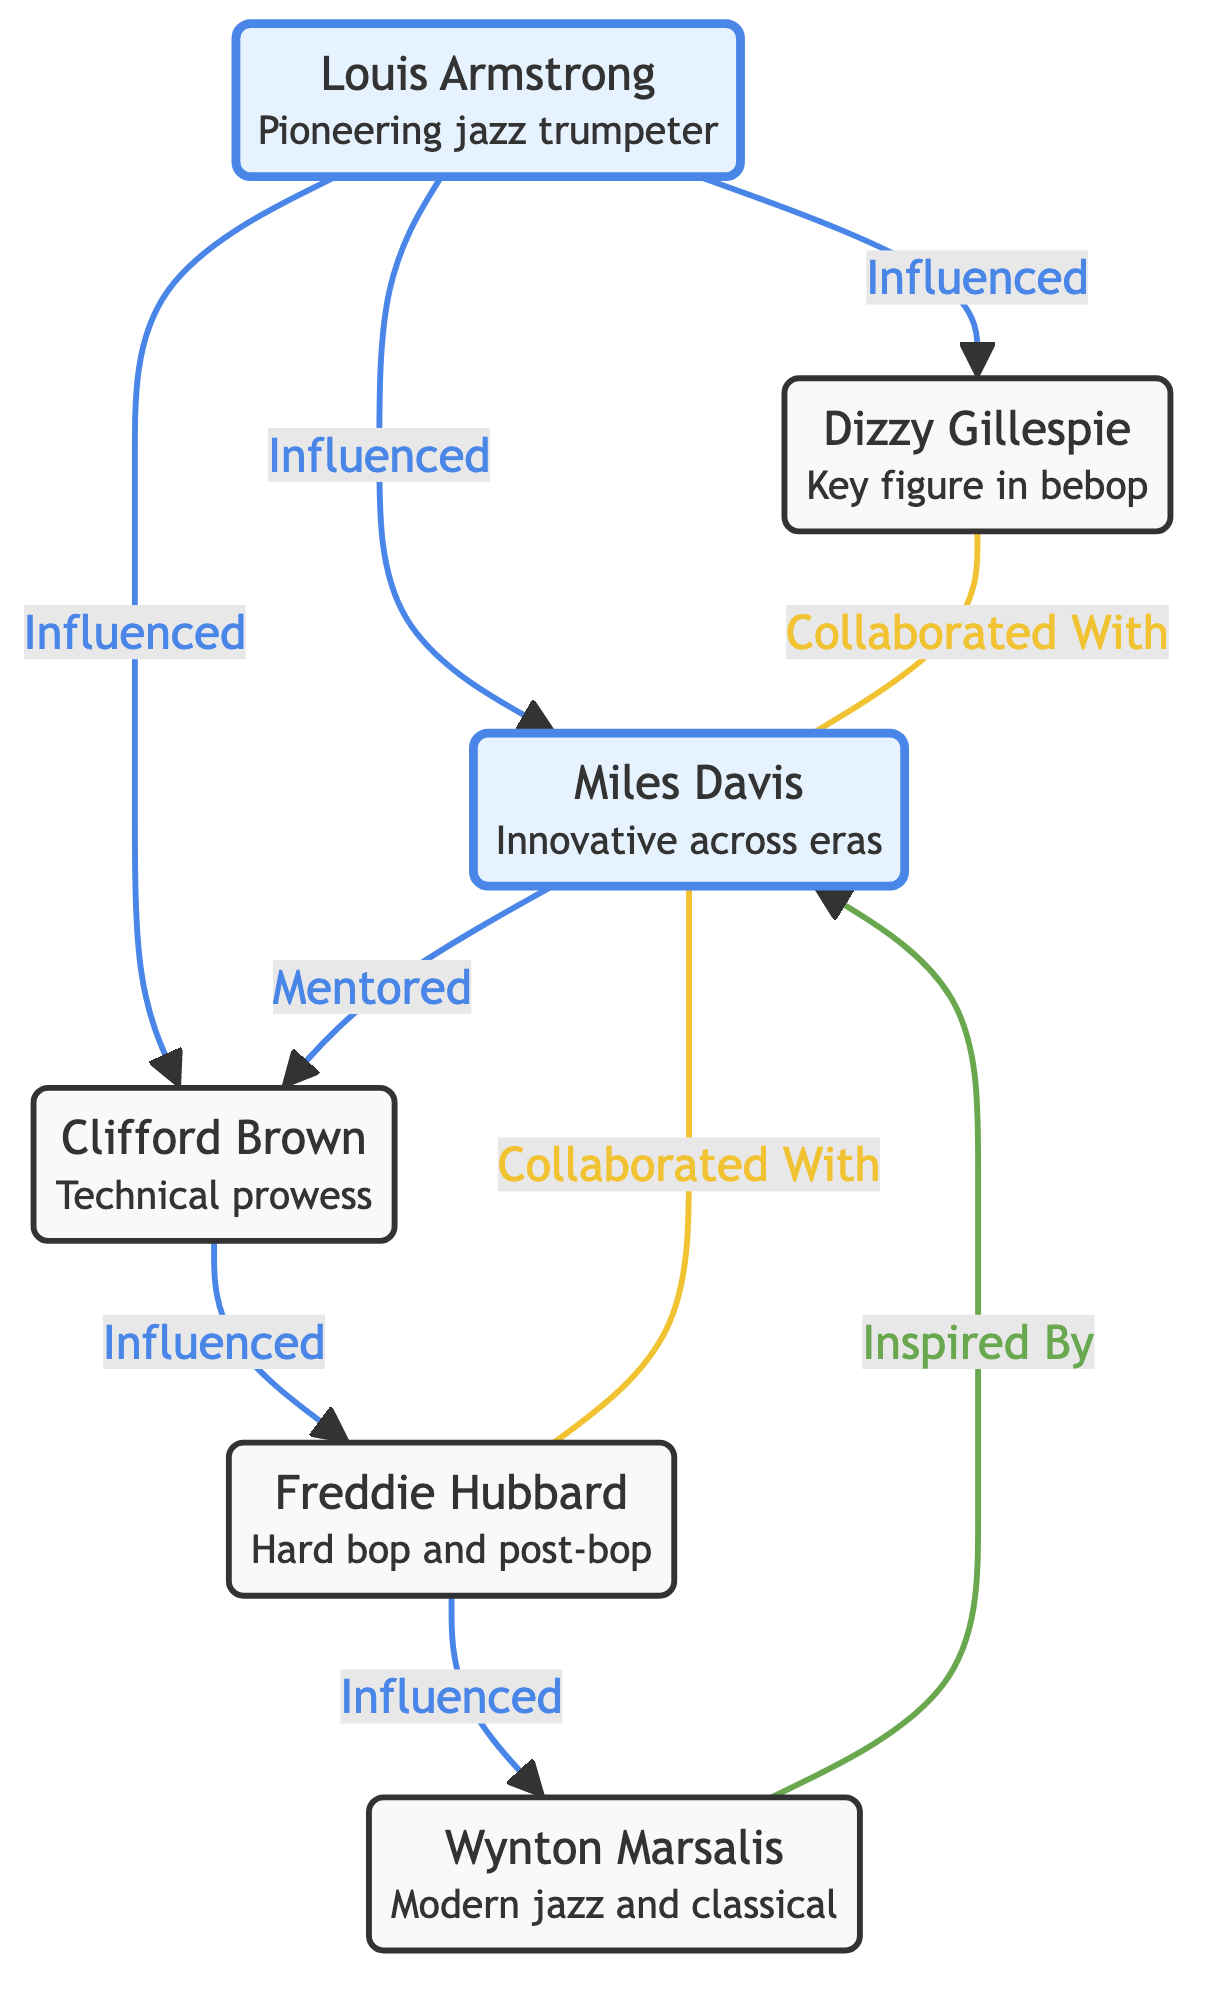What is the total number of trumpet players in the diagram? The diagram features a list of nodes that represent individual trumpet players. By counting each unique player node, we find there are six players represented.
Answer: 6 Who influenced Dizzy Gillespie? The arrow originating from Louis Armstrong pointing to Dizzy Gillespie indicates that he influenced Gillespie. Thus, Louis Armstrong is the correct answer based on the relationship shown in the diagram.
Answer: Louis Armstrong Which musician did Miles Davis mentor? The arrow leading from Miles Davis to Clifford Brown shows that Davis mentored Brown. This relationship is clearly indicated in the network, making the answer easy to identify.
Answer: Clifford Brown How many collaborations are depicted in the diagram? By examining the connections labeled as "Collaborated With," we find there are two such relationships, one between Dizzy Gillespie and Miles Davis, and another between Miles Davis and Freddie Hubbard. Thus, the total is two.
Answer: 2 Who is influenced by Freddie Hubbard? The arrow from Freddie Hubbard to Wynton Marsalis signifies that Hubbard influenced Marsalis. By following the direction of the arrows, we can conclude that the answer is Wynton Marsalis.
Answer: Wynton Marsalis Which trumpeter is inspired by Miles Davis? The arrow pointing from Wynton Marsalis to Miles Davis is labeled "Inspired By," indicating that Marsalis is inspired by Davis. This relationship is directly stated in the diagram.
Answer: Miles Davis What is the relationship between Clifford Brown and Freddie Hubbard? The diagram shows an arrow from Clifford Brown to Freddie Hubbard labeled "Influenced." This indicates the type of relationship between these two musicians clearly.
Answer: Influenced Which trumpet player is recognized for his contributions to bebop? The description of Dizzy Gillespie states he is a key figure in the development of bebop. Therefore, by looking at the nodes and understanding their descriptions, we can conclude the answer is Dizzy Gillespie.
Answer: Dizzy Gillespie How many direct influences does Louis Armstrong have? By inspecting the arrows spreading out from Louis Armstrong, we can see that he has three direct influences: Dizzy Gillespie, Miles Davis, and Clifford Brown. Thus, the total number of direct influences is three.
Answer: 3 